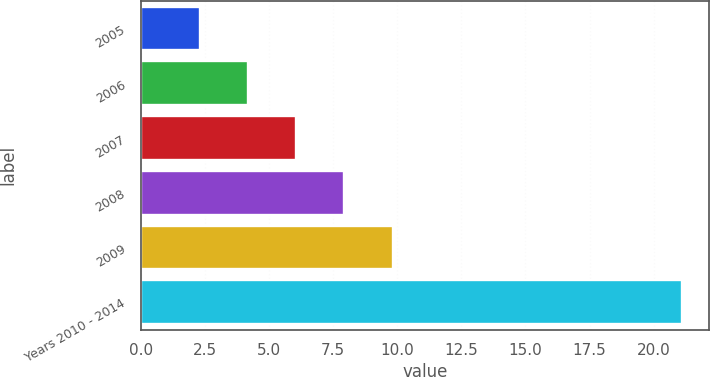Convert chart to OTSL. <chart><loc_0><loc_0><loc_500><loc_500><bar_chart><fcel>2005<fcel>2006<fcel>2007<fcel>2008<fcel>2009<fcel>Years 2010 - 2014<nl><fcel>2.3<fcel>4.18<fcel>6.06<fcel>7.94<fcel>9.82<fcel>21.1<nl></chart> 